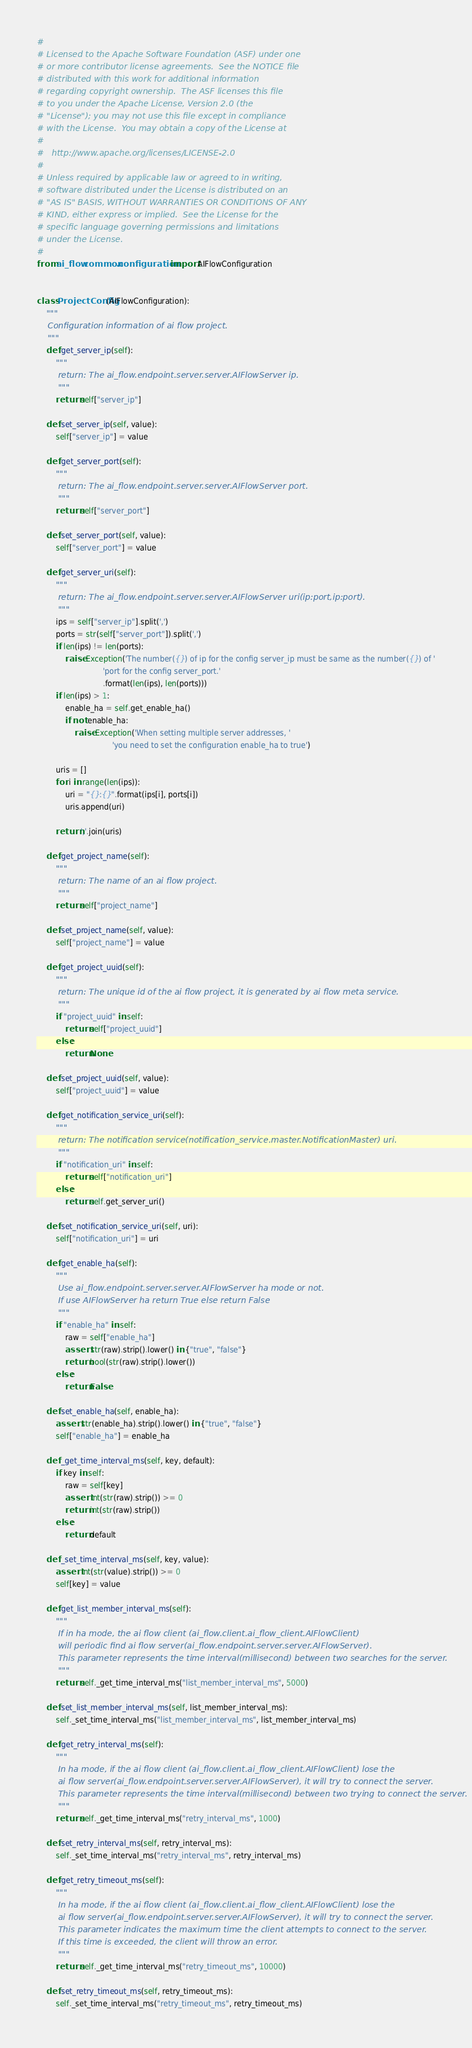<code> <loc_0><loc_0><loc_500><loc_500><_Python_>#
# Licensed to the Apache Software Foundation (ASF) under one
# or more contributor license agreements.  See the NOTICE file
# distributed with this work for additional information
# regarding copyright ownership.  The ASF licenses this file
# to you under the Apache License, Version 2.0 (the
# "License"); you may not use this file except in compliance
# with the License.  You may obtain a copy of the License at
#
#   http://www.apache.org/licenses/LICENSE-2.0
#
# Unless required by applicable law or agreed to in writing,
# software distributed under the License is distributed on an
# "AS IS" BASIS, WITHOUT WARRANTIES OR CONDITIONS OF ANY
# KIND, either express or implied.  See the License for the
# specific language governing permissions and limitations
# under the License.
#
from ai_flow.common.configuration import AIFlowConfiguration


class ProjectConfig(AIFlowConfiguration):
    """
    Configuration information of ai flow project.
    """
    def get_server_ip(self):
        """
        return: The ai_flow.endpoint.server.server.AIFlowServer ip.
        """
        return self["server_ip"]

    def set_server_ip(self, value):
        self["server_ip"] = value

    def get_server_port(self):
        """
        return: The ai_flow.endpoint.server.server.AIFlowServer port.
        """
        return self["server_port"]

    def set_server_port(self, value):
        self["server_port"] = value

    def get_server_uri(self):
        """
        return: The ai_flow.endpoint.server.server.AIFlowServer uri(ip:port,ip:port).
        """
        ips = self["server_ip"].split(',')
        ports = str(self["server_port"]).split(',')
        if len(ips) != len(ports):
            raise Exception('The number({}) of ip for the config server_ip must be same as the number({}) of '
                            'port for the config server_port.'
                            .format(len(ips), len(ports)))
        if len(ips) > 1:
            enable_ha = self.get_enable_ha()
            if not enable_ha:
                raise Exception('When setting multiple server addresses, '
                                'you need to set the configuration enable_ha to true')

        uris = []
        for i in range(len(ips)):
            uri = "{}:{}".format(ips[i], ports[i])
            uris.append(uri)

        return ','.join(uris)

    def get_project_name(self):
        """
        return: The name of an ai flow project.
        """
        return self["project_name"]

    def set_project_name(self, value):
        self["project_name"] = value

    def get_project_uuid(self):
        """
        return: The unique id of the ai flow project, it is generated by ai flow meta service.
        """
        if "project_uuid" in self:
            return self["project_uuid"]
        else:
            return None

    def set_project_uuid(self, value):
        self["project_uuid"] = value

    def get_notification_service_uri(self):
        """
        return: The notification service(notification_service.master.NotificationMaster) uri.
        """
        if "notification_uri" in self:
            return self["notification_uri"]
        else:
            return self.get_server_uri()

    def set_notification_service_uri(self, uri):
        self["notification_uri"] = uri

    def get_enable_ha(self):
        """
        Use ai_flow.endpoint.server.server.AIFlowServer ha mode or not.
        If use AIFlowServer ha return True else return False
        """
        if "enable_ha" in self:
            raw = self["enable_ha"]
            assert str(raw).strip().lower() in {"true", "false"}
            return bool(str(raw).strip().lower())
        else:
            return False

    def set_enable_ha(self, enable_ha):
        assert str(enable_ha).strip().lower() in {"true", "false"}
        self["enable_ha"] = enable_ha

    def _get_time_interval_ms(self, key, default):
        if key in self:
            raw = self[key]
            assert int(str(raw).strip()) >= 0
            return int(str(raw).strip())
        else:
            return default

    def _set_time_interval_ms(self, key, value):
        assert int(str(value).strip()) >= 0
        self[key] = value

    def get_list_member_interval_ms(self):
        """
        If in ha mode, the ai flow client (ai_flow.client.ai_flow_client.AIFlowClient)
        will periodic find ai flow server(ai_flow.endpoint.server.server.AIFlowServer).
        This parameter represents the time interval(millisecond) between two searches for the server.
        """
        return self._get_time_interval_ms("list_member_interval_ms", 5000)

    def set_list_member_interval_ms(self, list_member_interval_ms):
        self._set_time_interval_ms("list_member_interval_ms", list_member_interval_ms)

    def get_retry_interval_ms(self):
        """
        In ha mode, if the ai flow client (ai_flow.client.ai_flow_client.AIFlowClient) lose the
        ai flow server(ai_flow.endpoint.server.server.AIFlowServer), it will try to connect the server.
        This parameter represents the time interval(millisecond) between two trying to connect the server.
        """
        return self._get_time_interval_ms("retry_interval_ms", 1000)

    def set_retry_interval_ms(self, retry_interval_ms):
        self._set_time_interval_ms("retry_interval_ms", retry_interval_ms)

    def get_retry_timeout_ms(self):
        """
        In ha mode, if the ai flow client (ai_flow.client.ai_flow_client.AIFlowClient) lose the
        ai flow server(ai_flow.endpoint.server.server.AIFlowServer), it will try to connect the server.
        This parameter indicates the maximum time the client attempts to connect to the server.
        If this time is exceeded, the client will throw an error.
        """
        return self._get_time_interval_ms("retry_timeout_ms", 10000)

    def set_retry_timeout_ms(self, retry_timeout_ms):
        self._set_time_interval_ms("retry_timeout_ms", retry_timeout_ms)

</code> 